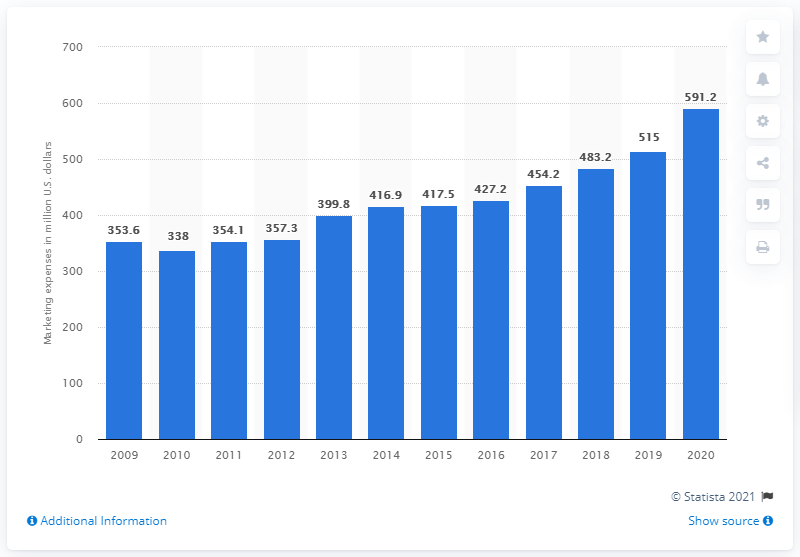Specify some key components in this picture. In 2020, the global marketing expenditure of Church & Dwight was 591.2 million dollars. 